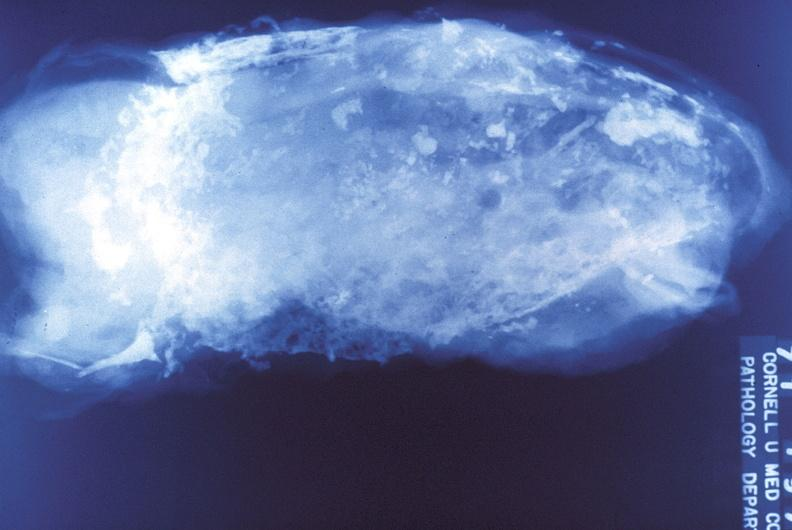where is this?
Answer the question using a single word or phrase. Lung 